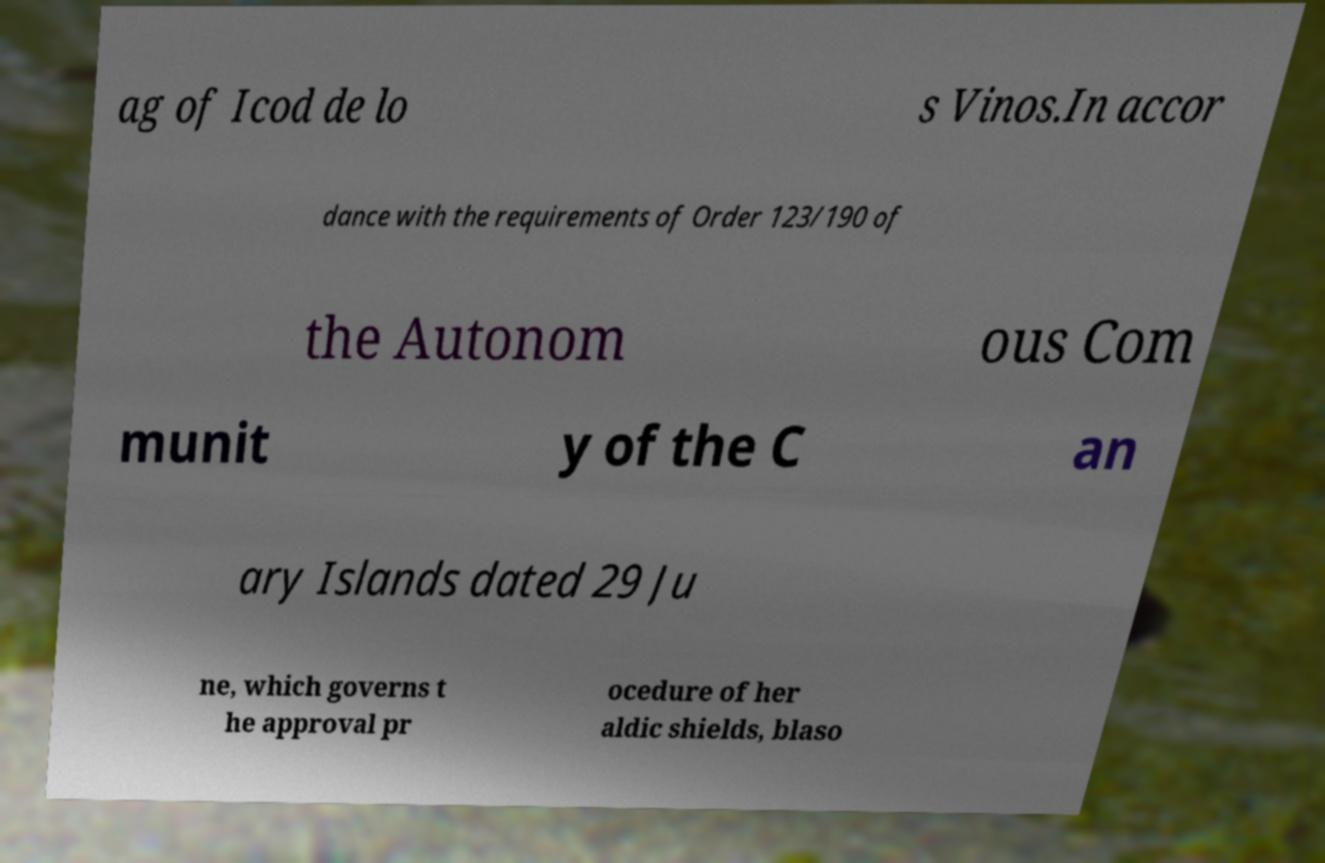Could you extract and type out the text from this image? ag of Icod de lo s Vinos.In accor dance with the requirements of Order 123/190 of the Autonom ous Com munit y of the C an ary Islands dated 29 Ju ne, which governs t he approval pr ocedure of her aldic shields, blaso 